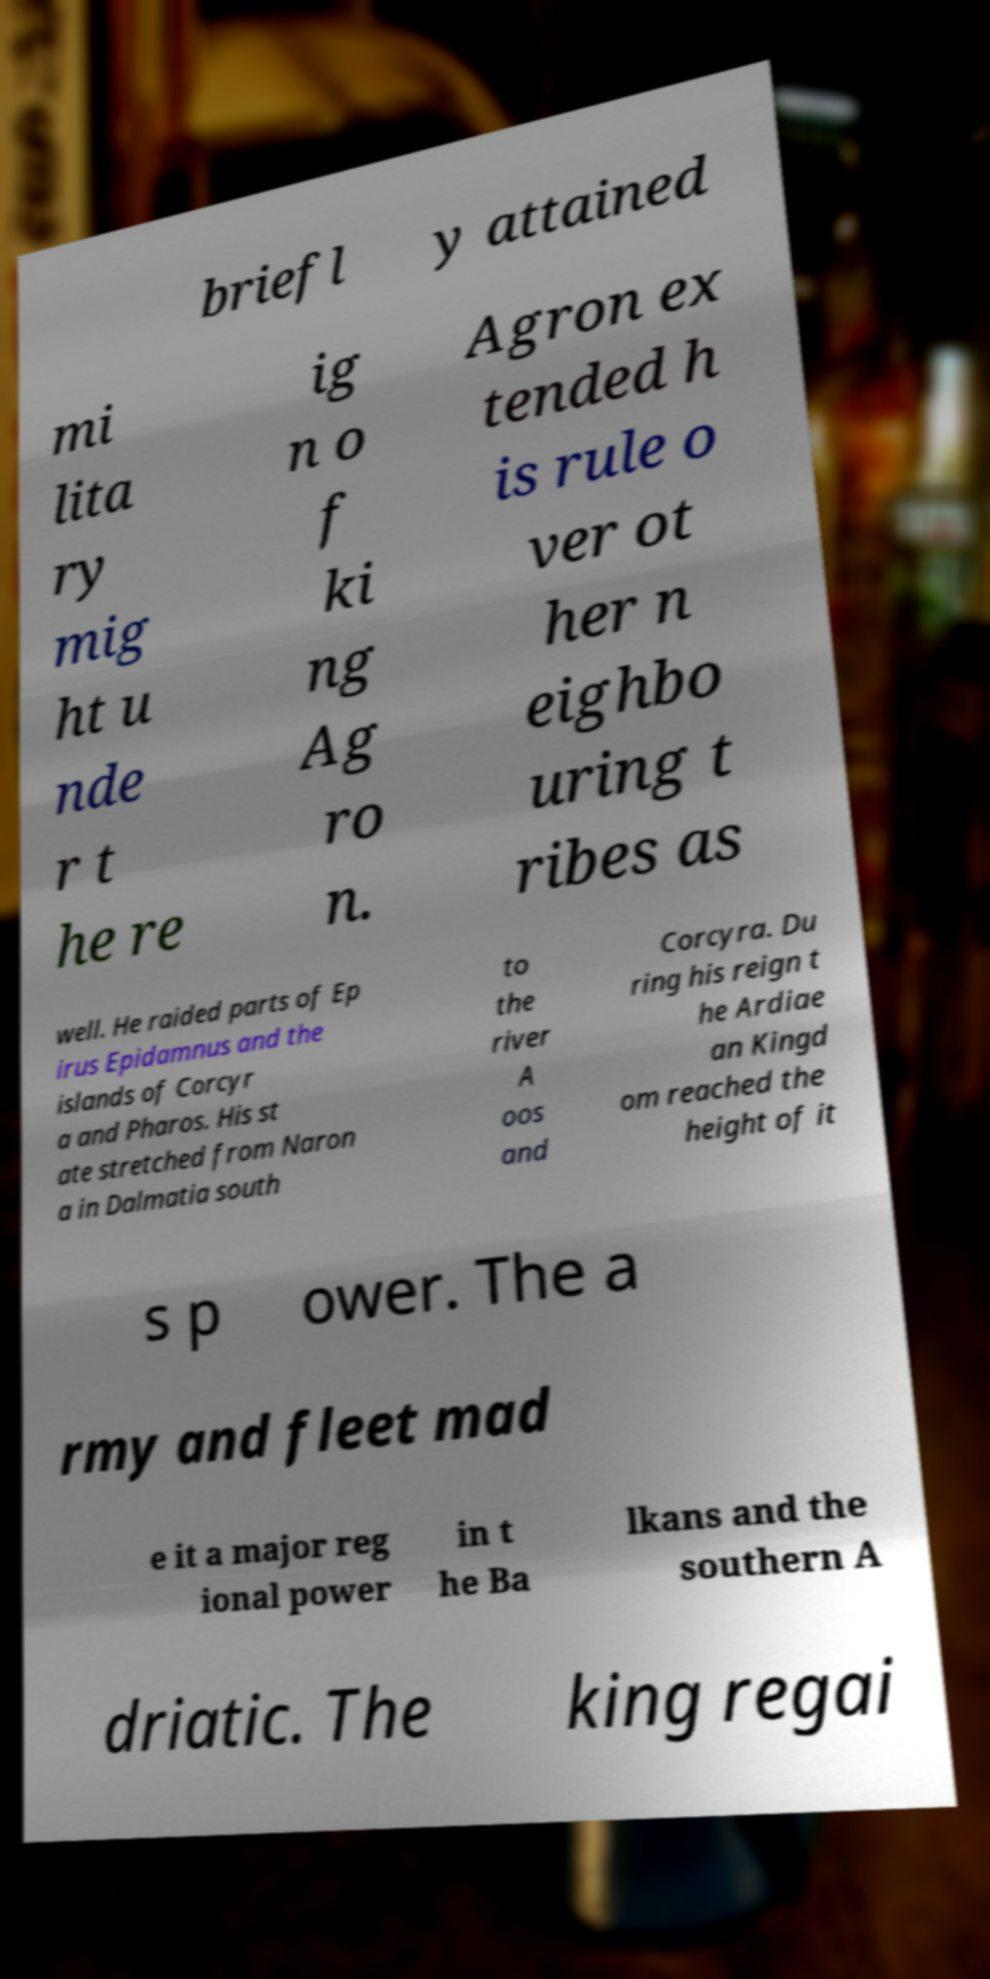Could you assist in decoding the text presented in this image and type it out clearly? briefl y attained mi lita ry mig ht u nde r t he re ig n o f ki ng Ag ro n. Agron ex tended h is rule o ver ot her n eighbo uring t ribes as well. He raided parts of Ep irus Epidamnus and the islands of Corcyr a and Pharos. His st ate stretched from Naron a in Dalmatia south to the river A oos and Corcyra. Du ring his reign t he Ardiae an Kingd om reached the height of it s p ower. The a rmy and fleet mad e it a major reg ional power in t he Ba lkans and the southern A driatic. The king regai 